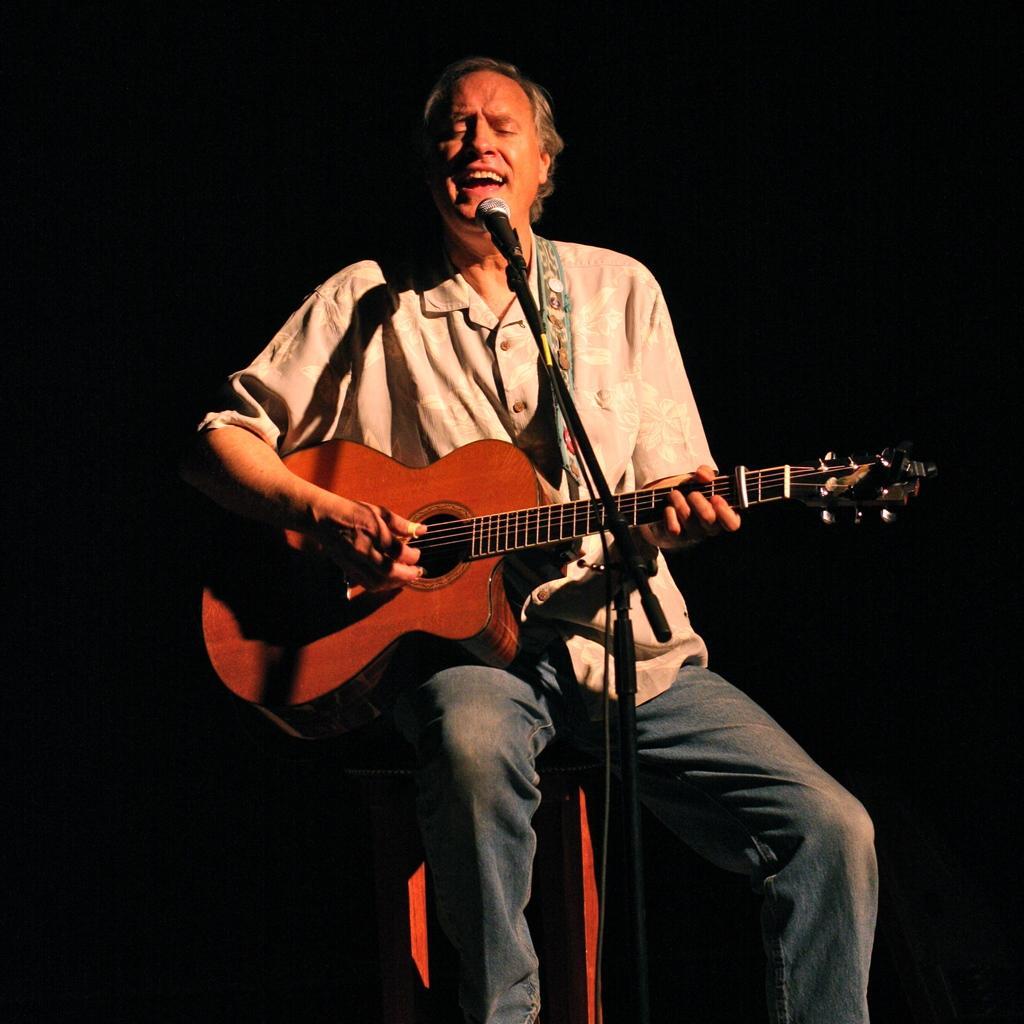Describe this image in one or two sentences. In this image I can see a man is sitting and holding a guitar. Here I can see a mic in front of him. 